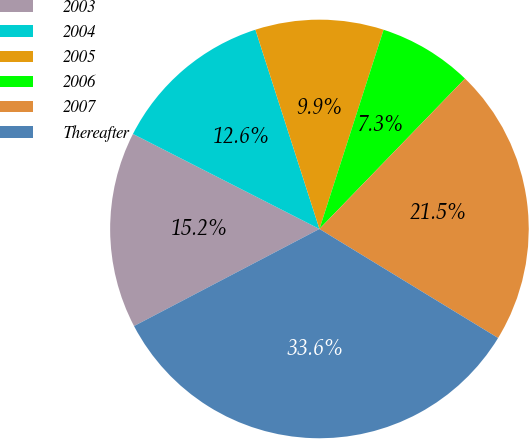Convert chart. <chart><loc_0><loc_0><loc_500><loc_500><pie_chart><fcel>2003<fcel>2004<fcel>2005<fcel>2006<fcel>2007<fcel>Thereafter<nl><fcel>15.18%<fcel>12.55%<fcel>9.91%<fcel>7.28%<fcel>21.48%<fcel>33.6%<nl></chart> 